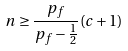Convert formula to latex. <formula><loc_0><loc_0><loc_500><loc_500>n \geq \frac { p _ { f } } { p _ { f } - \frac { 1 } { 2 } } ( c + 1 )</formula> 